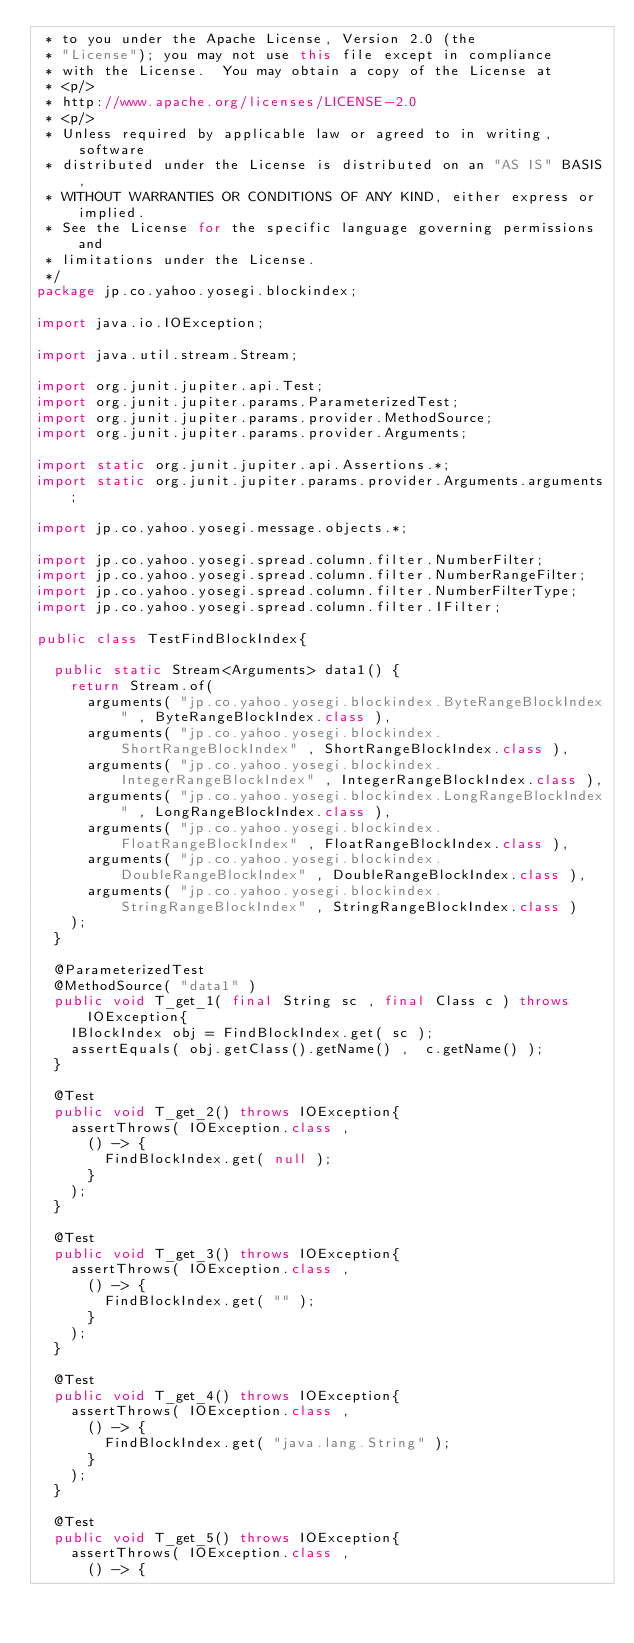<code> <loc_0><loc_0><loc_500><loc_500><_Java_> * to you under the Apache License, Version 2.0 (the
 * "License"); you may not use this file except in compliance
 * with the License.  You may obtain a copy of the License at
 * <p/>
 * http://www.apache.org/licenses/LICENSE-2.0
 * <p/>
 * Unless required by applicable law or agreed to in writing, software
 * distributed under the License is distributed on an "AS IS" BASIS,
 * WITHOUT WARRANTIES OR CONDITIONS OF ANY KIND, either express or implied.
 * See the License for the specific language governing permissions and
 * limitations under the License.
 */
package jp.co.yahoo.yosegi.blockindex;

import java.io.IOException;

import java.util.stream.Stream;

import org.junit.jupiter.api.Test;
import org.junit.jupiter.params.ParameterizedTest;
import org.junit.jupiter.params.provider.MethodSource;
import org.junit.jupiter.params.provider.Arguments;

import static org.junit.jupiter.api.Assertions.*;
import static org.junit.jupiter.params.provider.Arguments.arguments;

import jp.co.yahoo.yosegi.message.objects.*;

import jp.co.yahoo.yosegi.spread.column.filter.NumberFilter;
import jp.co.yahoo.yosegi.spread.column.filter.NumberRangeFilter;
import jp.co.yahoo.yosegi.spread.column.filter.NumberFilterType;
import jp.co.yahoo.yosegi.spread.column.filter.IFilter;

public class TestFindBlockIndex{

  public static Stream<Arguments> data1() {
    return Stream.of(
      arguments( "jp.co.yahoo.yosegi.blockindex.ByteRangeBlockIndex" , ByteRangeBlockIndex.class ),
      arguments( "jp.co.yahoo.yosegi.blockindex.ShortRangeBlockIndex" , ShortRangeBlockIndex.class ),
      arguments( "jp.co.yahoo.yosegi.blockindex.IntegerRangeBlockIndex" , IntegerRangeBlockIndex.class ),
      arguments( "jp.co.yahoo.yosegi.blockindex.LongRangeBlockIndex" , LongRangeBlockIndex.class ),
      arguments( "jp.co.yahoo.yosegi.blockindex.FloatRangeBlockIndex" , FloatRangeBlockIndex.class ),
      arguments( "jp.co.yahoo.yosegi.blockindex.DoubleRangeBlockIndex" , DoubleRangeBlockIndex.class ),
      arguments( "jp.co.yahoo.yosegi.blockindex.StringRangeBlockIndex" , StringRangeBlockIndex.class )
    );
  }

  @ParameterizedTest
  @MethodSource( "data1" )
  public void T_get_1( final String sc , final Class c ) throws IOException{
    IBlockIndex obj = FindBlockIndex.get( sc );
    assertEquals( obj.getClass().getName() ,  c.getName() );
  }

  @Test
  public void T_get_2() throws IOException{
    assertThrows( IOException.class ,
      () -> {
        FindBlockIndex.get( null );
      }
    );
  }

  @Test
  public void T_get_3() throws IOException{
    assertThrows( IOException.class ,
      () -> {
        FindBlockIndex.get( "" );
      }
    );
  }

  @Test
  public void T_get_4() throws IOException{
    assertThrows( IOException.class ,
      () -> {
        FindBlockIndex.get( "java.lang.String" );
      }
    );
  }

  @Test
  public void T_get_5() throws IOException{
    assertThrows( IOException.class ,
      () -> {</code> 